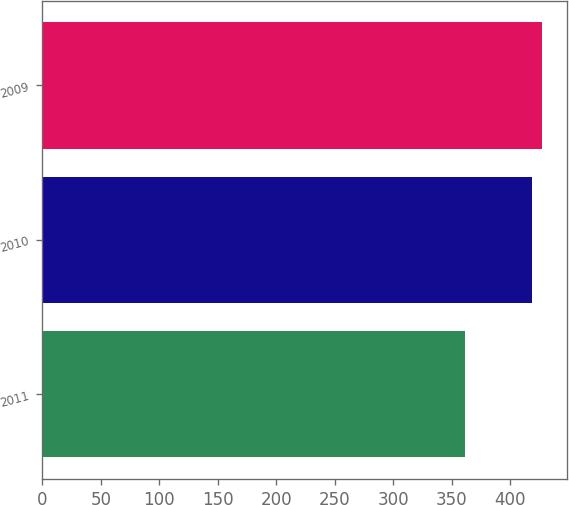<chart> <loc_0><loc_0><loc_500><loc_500><bar_chart><fcel>2011<fcel>2010<fcel>2009<nl><fcel>361<fcel>419<fcel>427<nl></chart> 